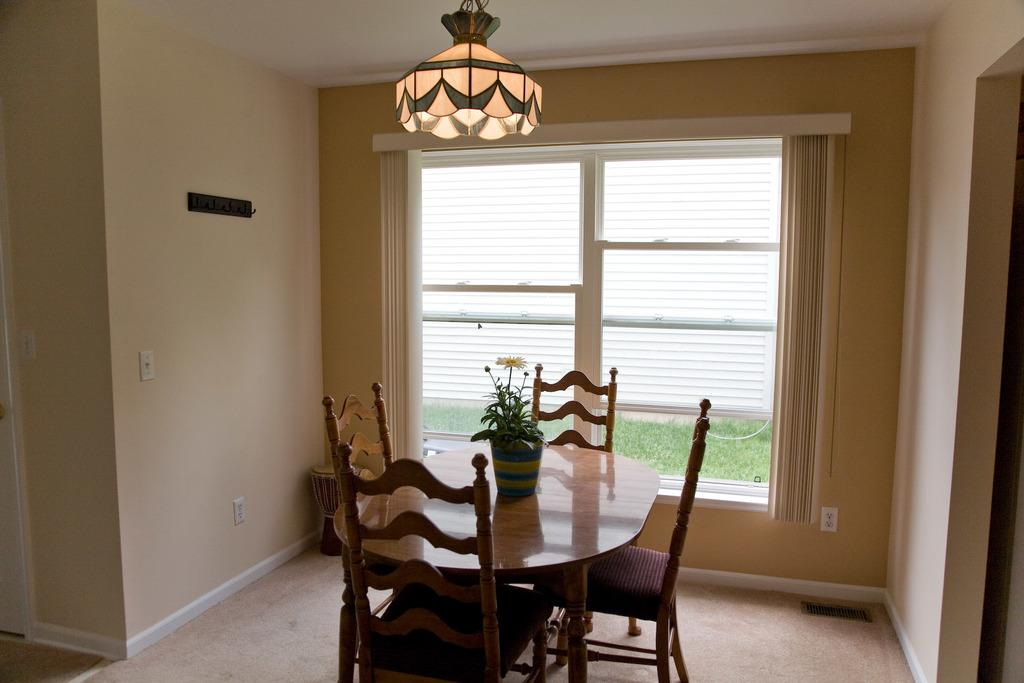What type of setting is depicted in the image? The image is an indoor scene. What type of furniture can be seen in the image? There are chairs and tables in the image. Is there any greenery present in the image? Yes, there is a plant on one of the tables. What can be seen through the window in the image? Grass is visible through the window. What type of lighting is present in the image? There is a light fixture in the image. What type of quilt is being used to cover the window during the rainstorm in the image? There is no quilt or rainstorm present in the image. The image shows an indoor scene with a window that has a clear view of grass outside. 